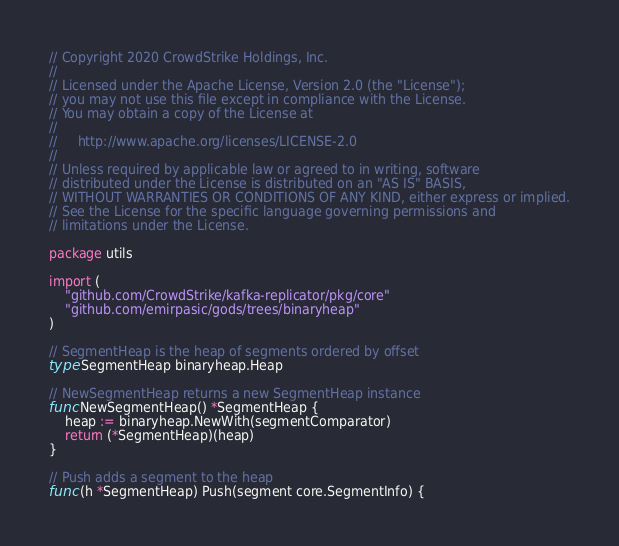Convert code to text. <code><loc_0><loc_0><loc_500><loc_500><_Go_>// Copyright 2020 CrowdStrike Holdings, Inc.
//
// Licensed under the Apache License, Version 2.0 (the "License");
// you may not use this file except in compliance with the License.
// You may obtain a copy of the License at
//
//     http://www.apache.org/licenses/LICENSE-2.0
//
// Unless required by applicable law or agreed to in writing, software
// distributed under the License is distributed on an "AS IS" BASIS,
// WITHOUT WARRANTIES OR CONDITIONS OF ANY KIND, either express or implied.
// See the License for the specific language governing permissions and
// limitations under the License.

package utils

import (
	"github.com/CrowdStrike/kafka-replicator/pkg/core"
	"github.com/emirpasic/gods/trees/binaryheap"
)

// SegmentHeap is the heap of segments ordered by offset
type SegmentHeap binaryheap.Heap

// NewSegmentHeap returns a new SegmentHeap instance
func NewSegmentHeap() *SegmentHeap {
	heap := binaryheap.NewWith(segmentComparator)
	return (*SegmentHeap)(heap)
}

// Push adds a segment to the heap
func (h *SegmentHeap) Push(segment core.SegmentInfo) {</code> 